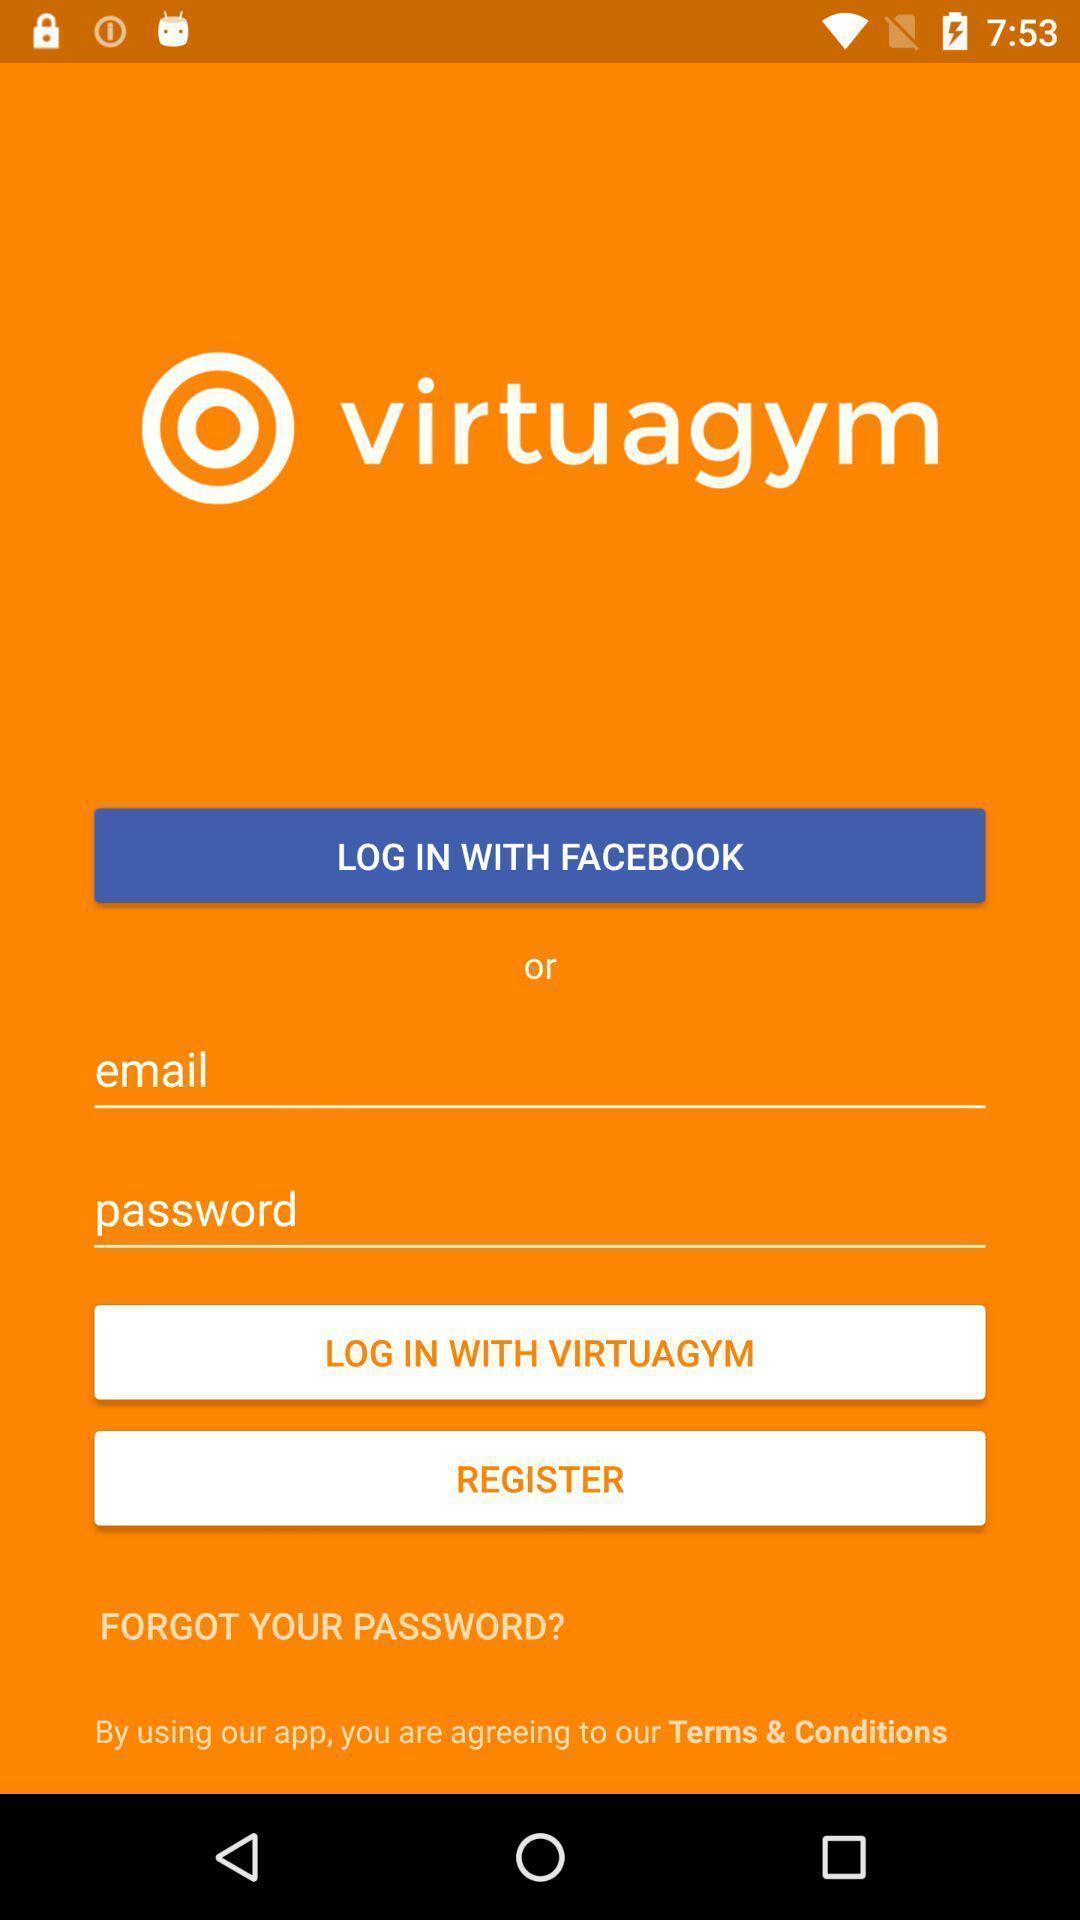Describe the key features of this screenshot. Welcome page. 